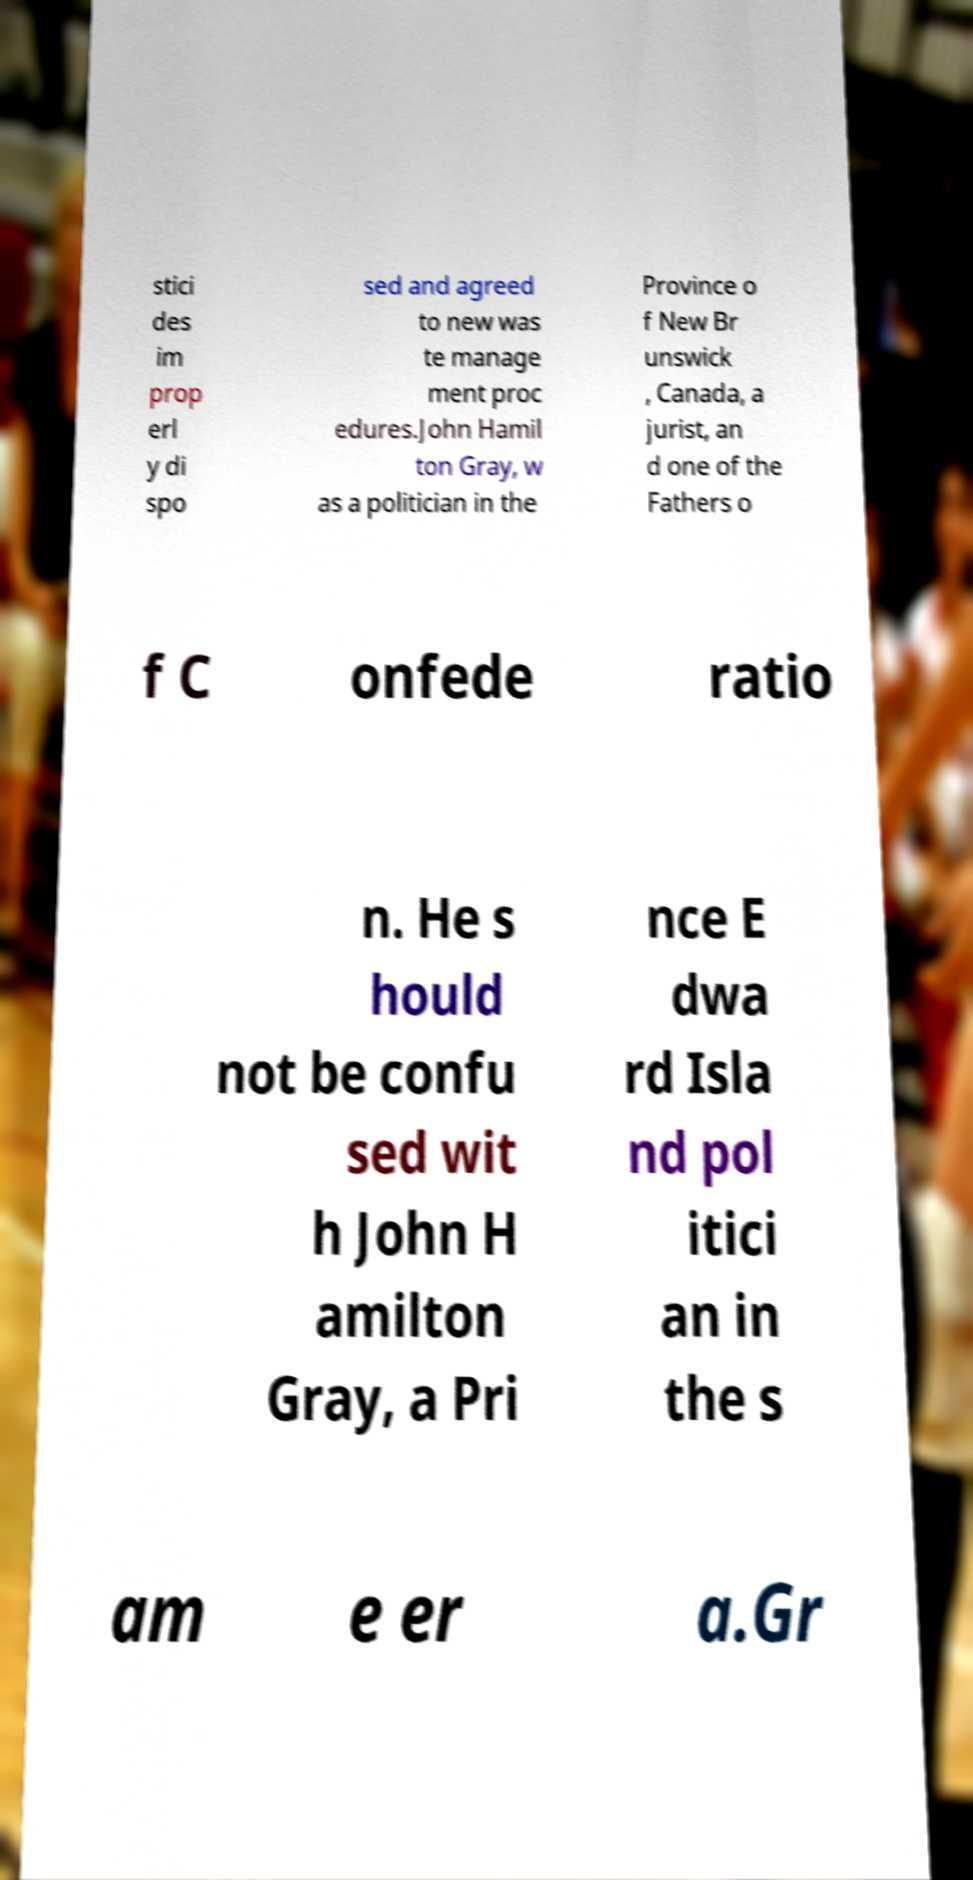Can you accurately transcribe the text from the provided image for me? stici des im prop erl y di spo sed and agreed to new was te manage ment proc edures.John Hamil ton Gray, w as a politician in the Province o f New Br unswick , Canada, a jurist, an d one of the Fathers o f C onfede ratio n. He s hould not be confu sed wit h John H amilton Gray, a Pri nce E dwa rd Isla nd pol itici an in the s am e er a.Gr 